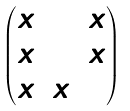<formula> <loc_0><loc_0><loc_500><loc_500>\begin{pmatrix} x & 0 & x \\ x & 0 & x \\ x & x & 0 \\ \end{pmatrix}</formula> 